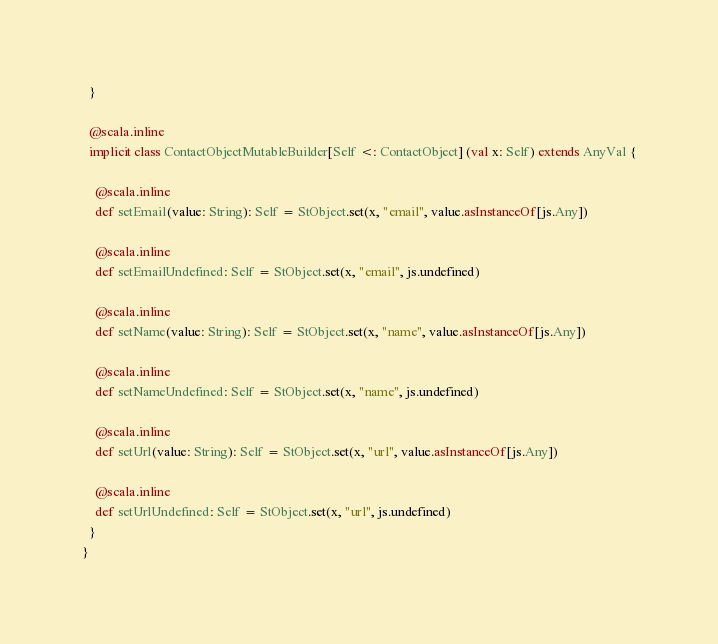<code> <loc_0><loc_0><loc_500><loc_500><_Scala_>  }
  
  @scala.inline
  implicit class ContactObjectMutableBuilder[Self <: ContactObject] (val x: Self) extends AnyVal {
    
    @scala.inline
    def setEmail(value: String): Self = StObject.set(x, "email", value.asInstanceOf[js.Any])
    
    @scala.inline
    def setEmailUndefined: Self = StObject.set(x, "email", js.undefined)
    
    @scala.inline
    def setName(value: String): Self = StObject.set(x, "name", value.asInstanceOf[js.Any])
    
    @scala.inline
    def setNameUndefined: Self = StObject.set(x, "name", js.undefined)
    
    @scala.inline
    def setUrl(value: String): Self = StObject.set(x, "url", value.asInstanceOf[js.Any])
    
    @scala.inline
    def setUrlUndefined: Self = StObject.set(x, "url", js.undefined)
  }
}
</code> 